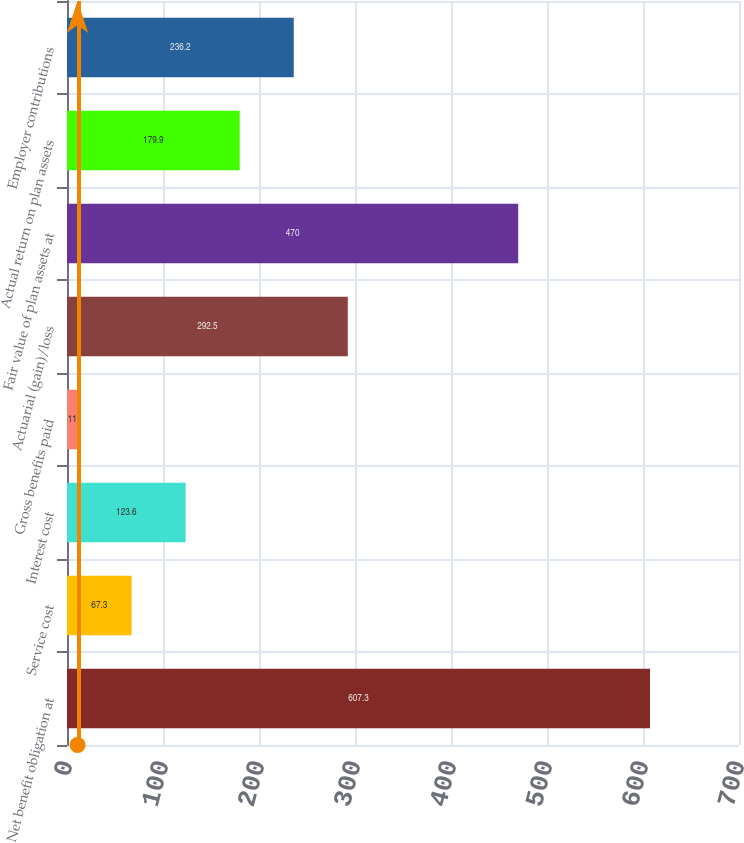Convert chart to OTSL. <chart><loc_0><loc_0><loc_500><loc_500><bar_chart><fcel>Net benefit obligation at<fcel>Service cost<fcel>Interest cost<fcel>Gross benefits paid<fcel>Actuarial (gain)/loss<fcel>Fair value of plan assets at<fcel>Actual return on plan assets<fcel>Employer contributions<nl><fcel>607.3<fcel>67.3<fcel>123.6<fcel>11<fcel>292.5<fcel>470<fcel>179.9<fcel>236.2<nl></chart> 